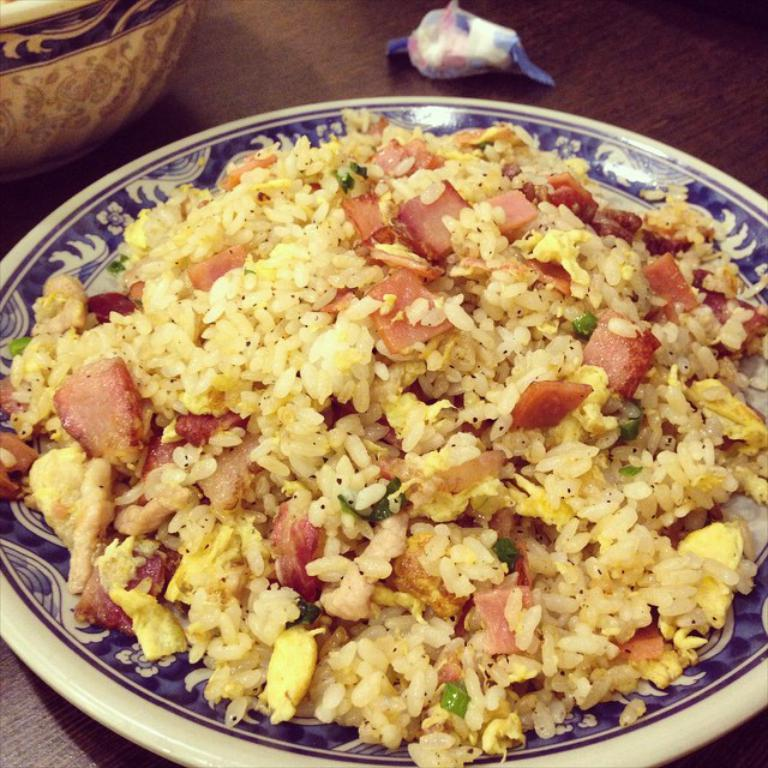What is the main subject in the center of the image? There is a food item in a plate in the center of the image. What type of furniture is present in the image? There is a table in the image. What other dish or container can be seen in the image? There is a bowl in the image. How many icicles are hanging from the food item in the image? There are no icicles present in the image. What type of apparel is being worn by the food item in the image? The food item in the image is not a living being and therefore cannot wear apparel. 